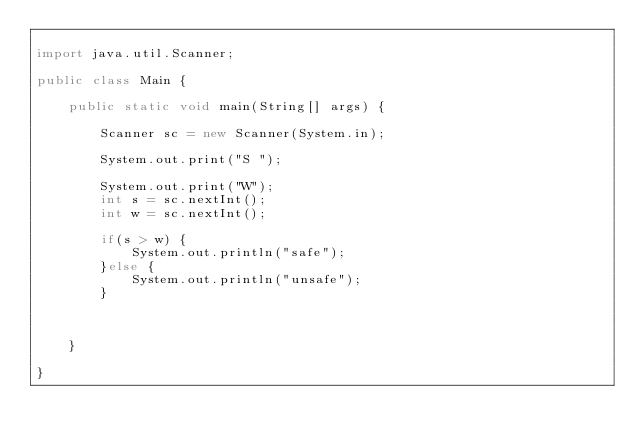<code> <loc_0><loc_0><loc_500><loc_500><_Java_>
import java.util.Scanner;

public class Main {

	public static void main(String[] args) {
		
		Scanner sc = new Scanner(System.in);
		
		System.out.print("S ");

		System.out.print("W");
		int s = sc.nextInt();
		int w = sc.nextInt();
		
		if(s > w) {
			System.out.println("safe");
		}else {
			System.out.println("unsafe");
		}
		
		

	}

}
</code> 